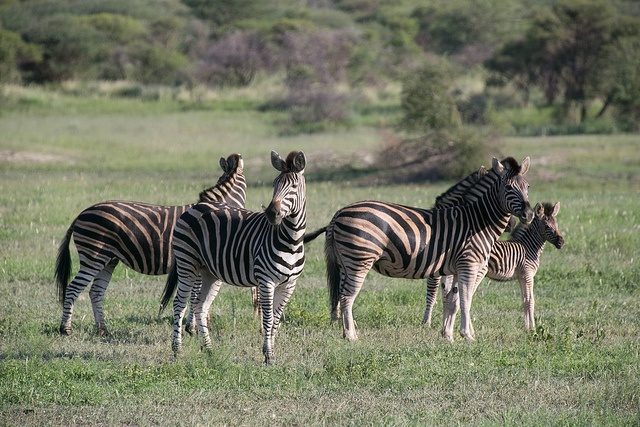Describe the objects in this image and their specific colors. I can see zebra in darkgreen, black, gray, lightgray, and darkgray tones, zebra in darkgreen, black, gray, darkgray, and lightgray tones, zebra in darkgreen, black, gray, and darkgray tones, and zebra in darkgreen, black, gray, lightgray, and darkgray tones in this image. 